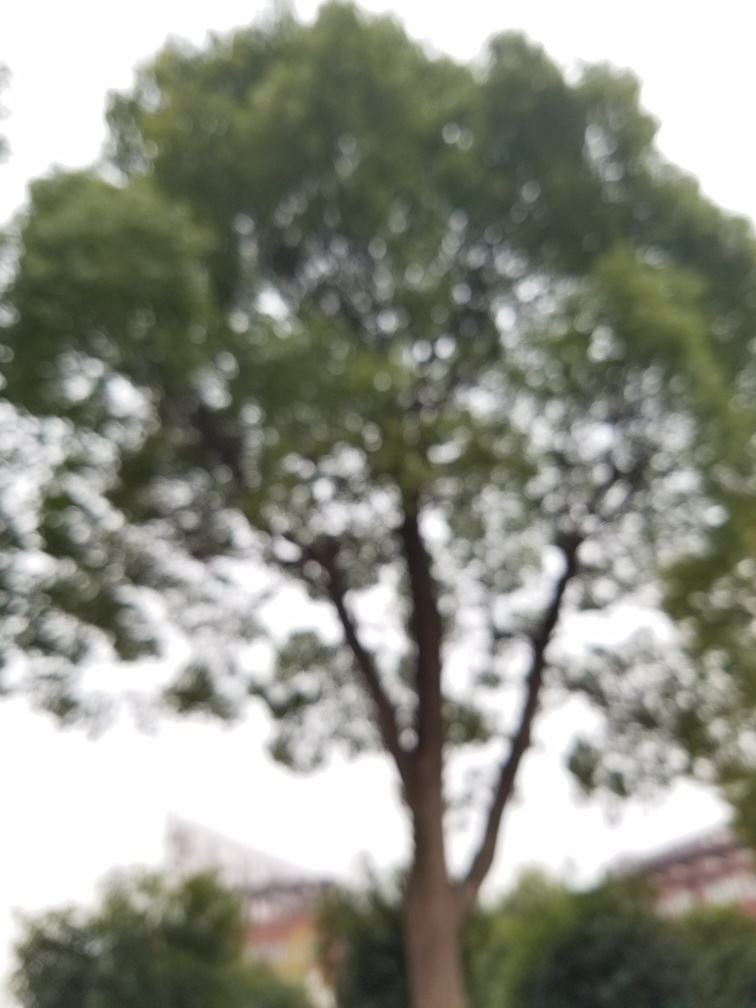What is the quality of this image? The quality of the image is suboptimal as it appears to be out of focus, causing the details of the tree and surroundings to be unclear. Proper focus is essential in photography to ensure that important elements within the frame are sharp and easily recognizable. This level of blurriness might be intentional for artistic effect, though for most practical purposes, a sharper image would be considered of higher quality. 